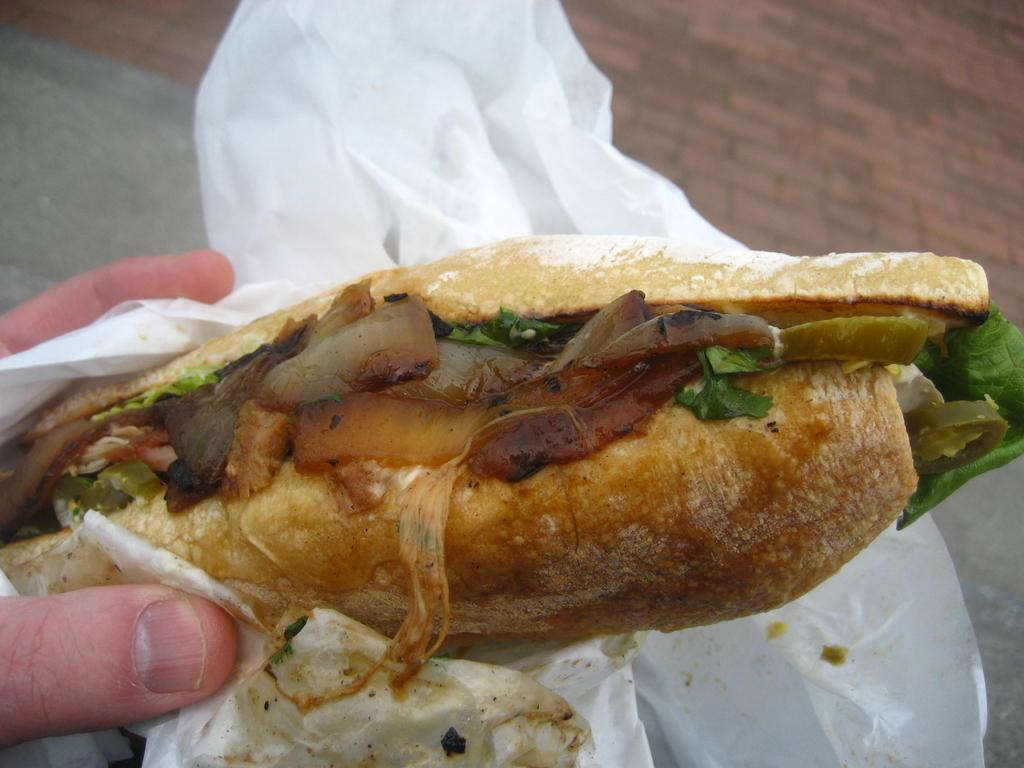What type of food is visible in the image? There is a sandwich in the image. How is the sandwich being held? A human hand is holding the sandwich. Is the sandwich covered or protected in any way? Yes, the sandwich is wrapped in paper. What type of science experiment is being conducted with the sandwich in the image? There is no science experiment being conducted with the sandwich in the image. 